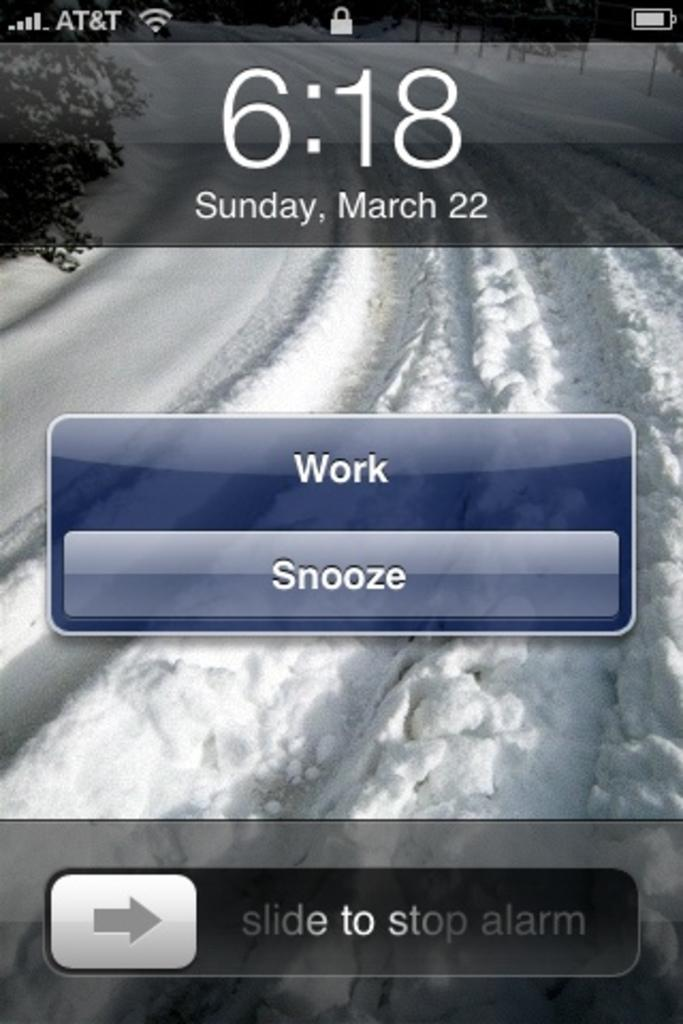<image>
Offer a succinct explanation of the picture presented. A iphone screen that shows the time of 6:18 on Sunday, March 22nd. 